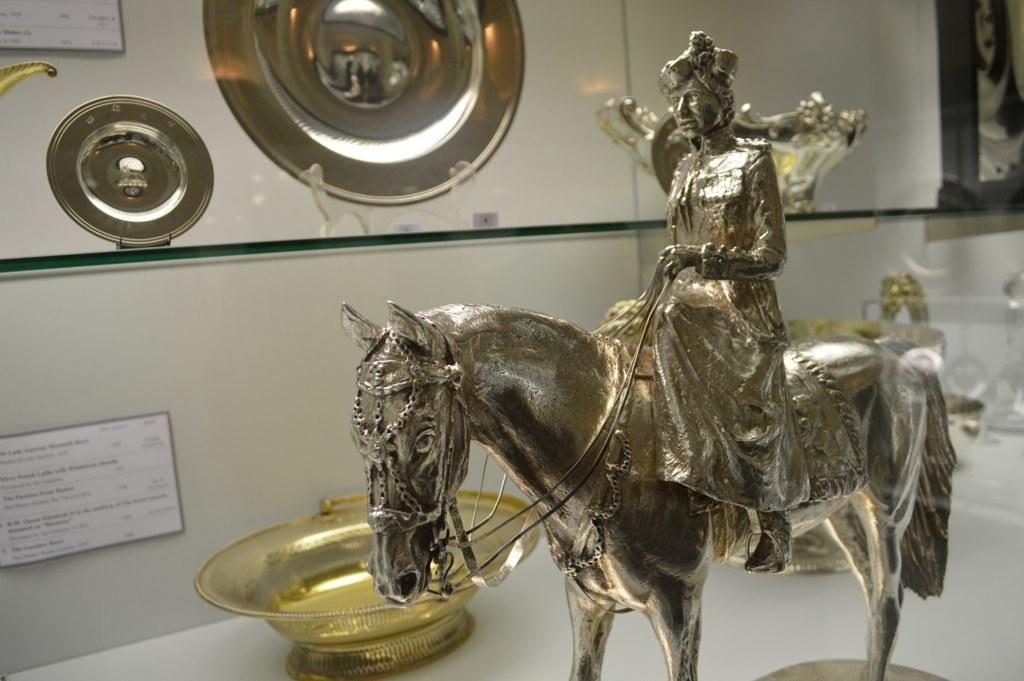What objects are present in the image? There are statues in the image. Can you describe something on the wall in the background of the image? There is a poster placed on the wall in the background of the image. What type of vessel can be seen carrying a pear in the image? There is no vessel carrying a pear present in the image. How many drops of water can be seen falling from the statues in the image? There is no reference to any drops of water in the image, as it features statues and a poster on the wall. 